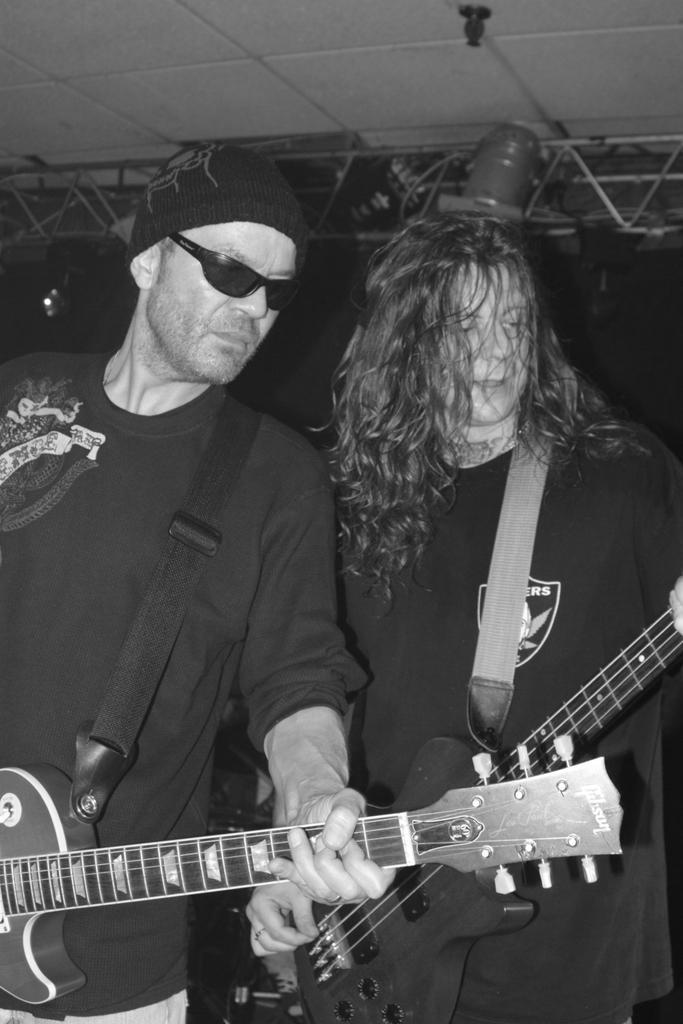Describe this image in one or two sentences. In this picture on the foreground there are two men standing holding guitars. In the background there is a ceiling frame of this stage. 